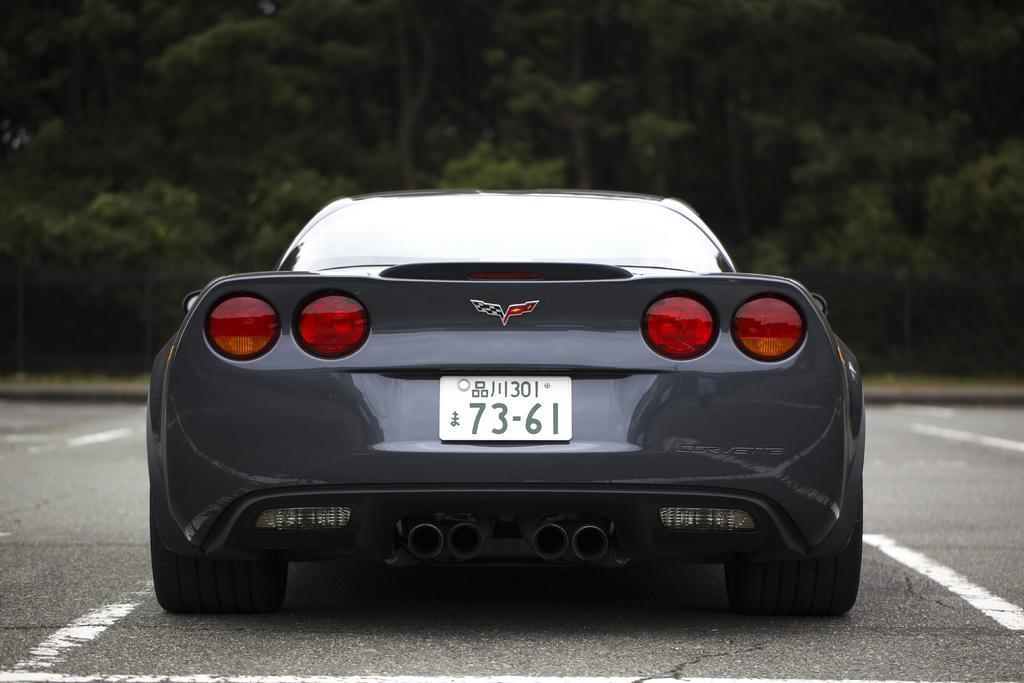<image>
Give a short and clear explanation of the subsequent image. A sports car has a license plate number of 73-61. 